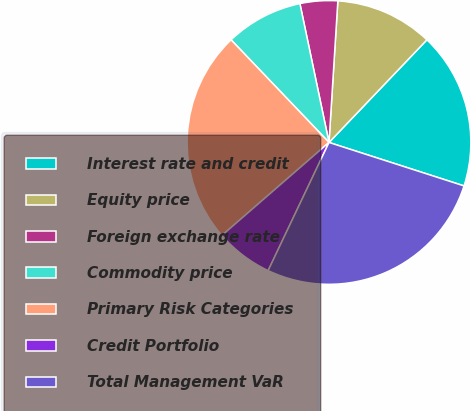Convert chart to OTSL. <chart><loc_0><loc_0><loc_500><loc_500><pie_chart><fcel>Interest rate and credit<fcel>Equity price<fcel>Foreign exchange rate<fcel>Commodity price<fcel>Primary Risk Categories<fcel>Credit Portfolio<fcel>Total Management VaR<nl><fcel>17.83%<fcel>11.13%<fcel>4.28%<fcel>8.84%<fcel>24.25%<fcel>6.56%<fcel>27.1%<nl></chart> 